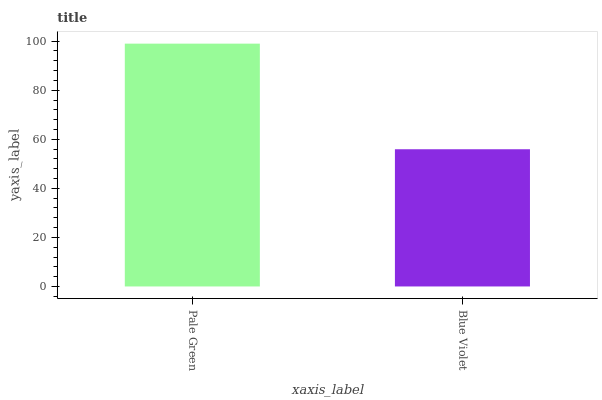Is Blue Violet the minimum?
Answer yes or no. Yes. Is Pale Green the maximum?
Answer yes or no. Yes. Is Blue Violet the maximum?
Answer yes or no. No. Is Pale Green greater than Blue Violet?
Answer yes or no. Yes. Is Blue Violet less than Pale Green?
Answer yes or no. Yes. Is Blue Violet greater than Pale Green?
Answer yes or no. No. Is Pale Green less than Blue Violet?
Answer yes or no. No. Is Pale Green the high median?
Answer yes or no. Yes. Is Blue Violet the low median?
Answer yes or no. Yes. Is Blue Violet the high median?
Answer yes or no. No. Is Pale Green the low median?
Answer yes or no. No. 